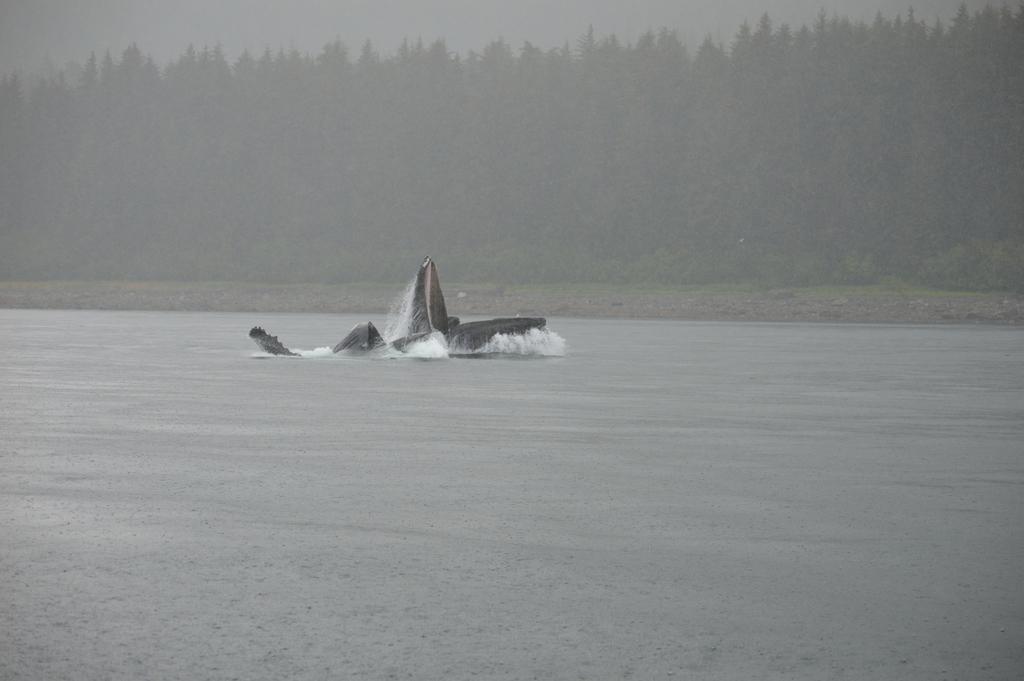Please provide a concise description of this image. In the middle of the picture, we see a boat sailing in the water. This water might be in the river. In the background, there are trees. 